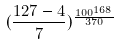Convert formula to latex. <formula><loc_0><loc_0><loc_500><loc_500>( \frac { 1 2 7 - 4 } { 7 } ) ^ { \frac { 1 0 0 ^ { 1 6 8 } } { 3 7 0 } }</formula> 